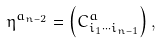Convert formula to latex. <formula><loc_0><loc_0><loc_500><loc_500>\eta ^ { a _ { n - 2 } } = \left ( C _ { i _ { 1 } \cdots i _ { n - 1 } } ^ { a } \right ) ,</formula> 